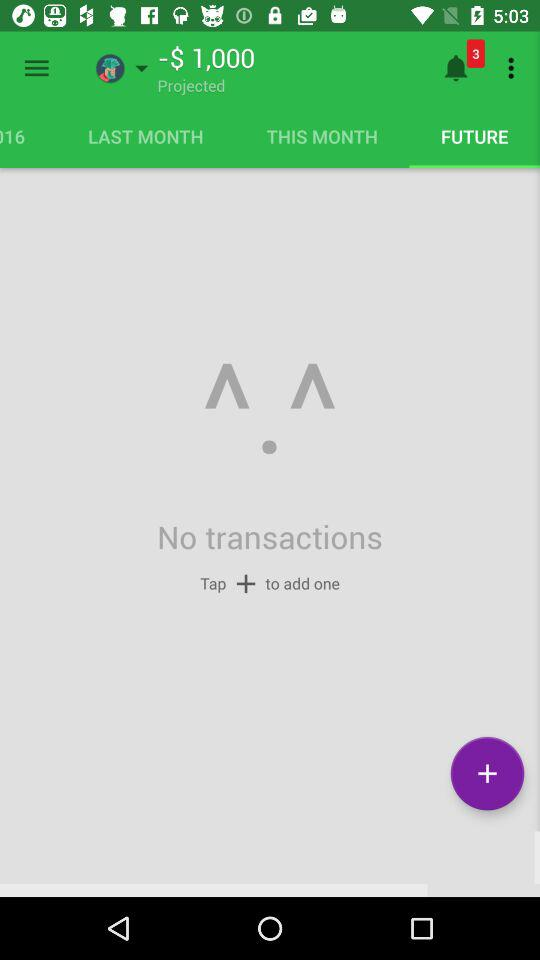How much is the projected amount? The projected amount is -$1,000. 